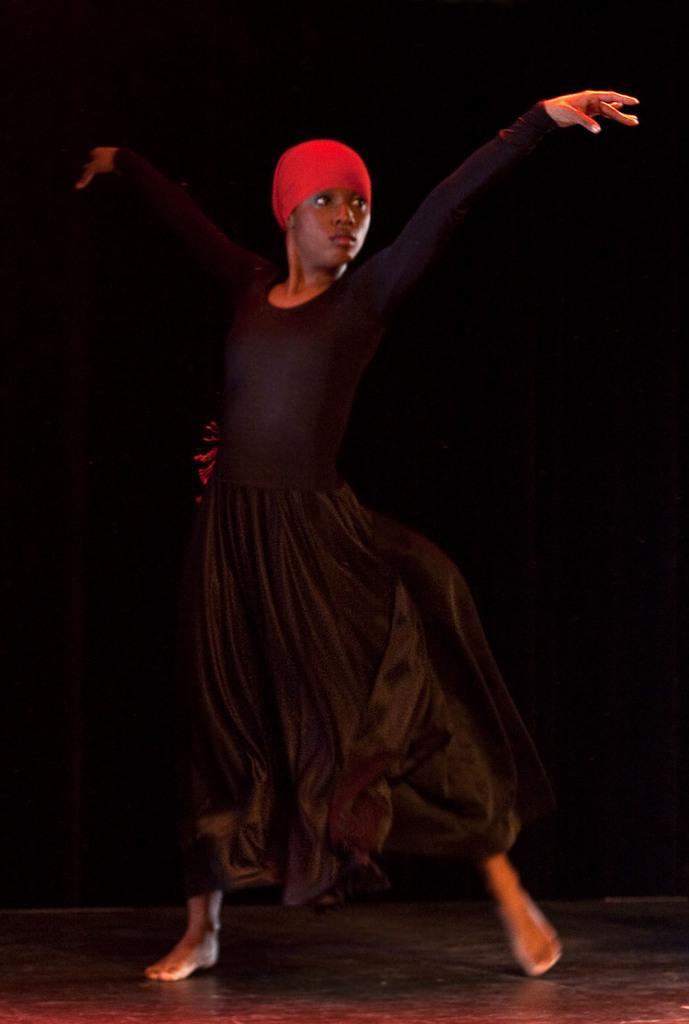Describe this image in one or two sentences. In this picture we can see a girl is dancing, she wore a black color dress, there is a dark background. 